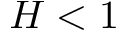Convert formula to latex. <formula><loc_0><loc_0><loc_500><loc_500>H < 1</formula> 